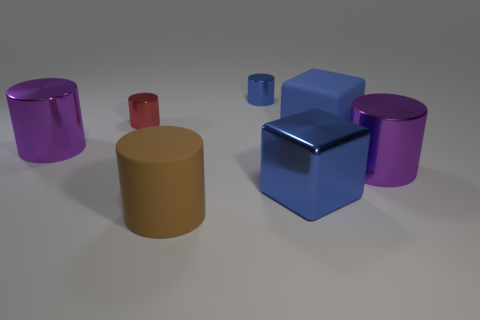Subtract all tiny blue shiny cylinders. How many cylinders are left? 4 Add 1 purple objects. How many objects exist? 8 Subtract all blue blocks. How many purple cylinders are left? 2 Subtract all purple cylinders. How many cylinders are left? 3 Subtract 2 cylinders. How many cylinders are left? 3 Add 3 big shiny blocks. How many big shiny blocks are left? 4 Add 4 matte cubes. How many matte cubes exist? 5 Subtract 0 blue spheres. How many objects are left? 7 Subtract all cubes. How many objects are left? 5 Subtract all green cylinders. Subtract all cyan cubes. How many cylinders are left? 5 